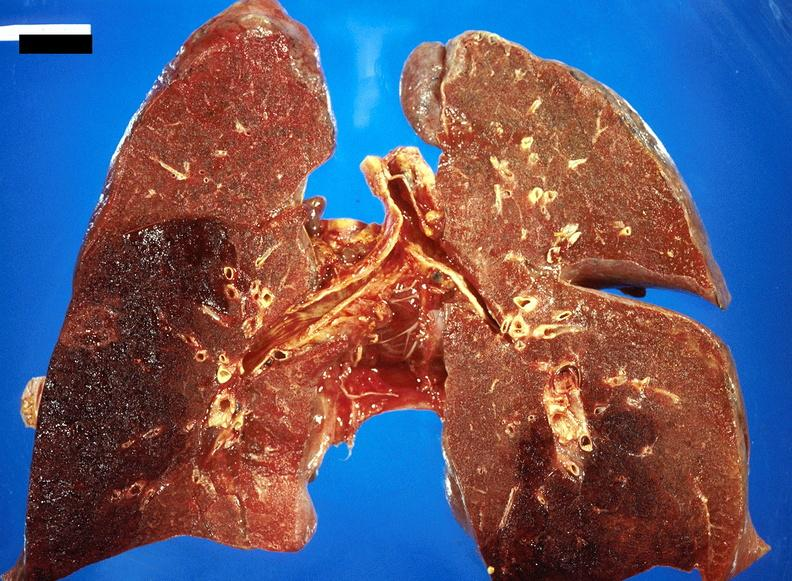where is this?
Answer the question using a single word or phrase. Lung 